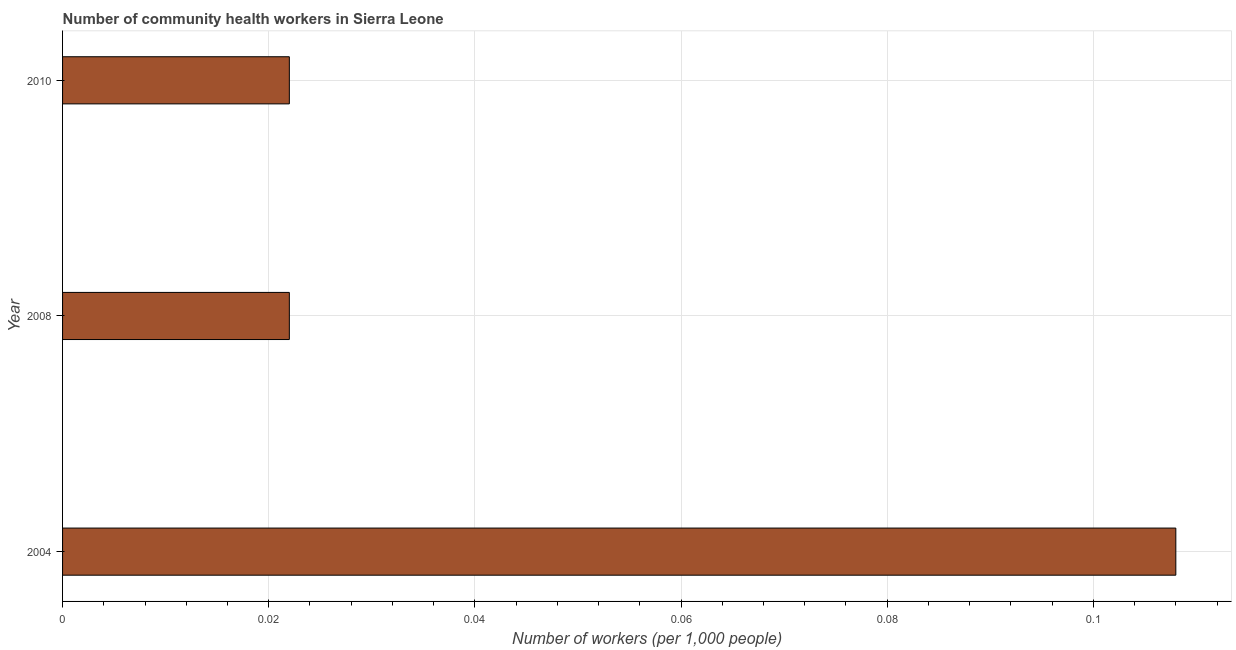Does the graph contain any zero values?
Your response must be concise. No. What is the title of the graph?
Offer a terse response. Number of community health workers in Sierra Leone. What is the label or title of the X-axis?
Your answer should be very brief. Number of workers (per 1,0 people). What is the label or title of the Y-axis?
Provide a succinct answer. Year. What is the number of community health workers in 2008?
Your response must be concise. 0.02. Across all years, what is the maximum number of community health workers?
Your answer should be very brief. 0.11. Across all years, what is the minimum number of community health workers?
Offer a very short reply. 0.02. In which year was the number of community health workers minimum?
Offer a terse response. 2008. What is the sum of the number of community health workers?
Offer a terse response. 0.15. What is the difference between the number of community health workers in 2004 and 2008?
Your response must be concise. 0.09. What is the average number of community health workers per year?
Offer a terse response. 0.05. What is the median number of community health workers?
Provide a succinct answer. 0.02. In how many years, is the number of community health workers greater than 0.02 ?
Offer a very short reply. 3. Is the difference between the number of community health workers in 2004 and 2010 greater than the difference between any two years?
Your response must be concise. Yes. What is the difference between the highest and the second highest number of community health workers?
Provide a short and direct response. 0.09. What is the difference between the highest and the lowest number of community health workers?
Offer a terse response. 0.09. How many bars are there?
Give a very brief answer. 3. What is the difference between two consecutive major ticks on the X-axis?
Make the answer very short. 0.02. What is the Number of workers (per 1,000 people) in 2004?
Provide a short and direct response. 0.11. What is the Number of workers (per 1,000 people) of 2008?
Provide a succinct answer. 0.02. What is the Number of workers (per 1,000 people) of 2010?
Make the answer very short. 0.02. What is the difference between the Number of workers (per 1,000 people) in 2004 and 2008?
Offer a terse response. 0.09. What is the difference between the Number of workers (per 1,000 people) in 2004 and 2010?
Offer a very short reply. 0.09. What is the ratio of the Number of workers (per 1,000 people) in 2004 to that in 2008?
Your answer should be compact. 4.91. What is the ratio of the Number of workers (per 1,000 people) in 2004 to that in 2010?
Offer a terse response. 4.91. What is the ratio of the Number of workers (per 1,000 people) in 2008 to that in 2010?
Give a very brief answer. 1. 